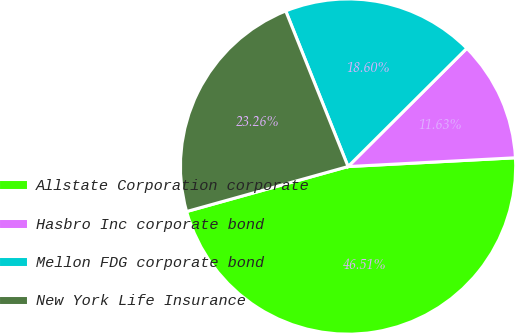Convert chart to OTSL. <chart><loc_0><loc_0><loc_500><loc_500><pie_chart><fcel>Allstate Corporation corporate<fcel>Hasbro Inc corporate bond<fcel>Mellon FDG corporate bond<fcel>New York Life Insurance<nl><fcel>46.51%<fcel>11.63%<fcel>18.6%<fcel>23.26%<nl></chart> 